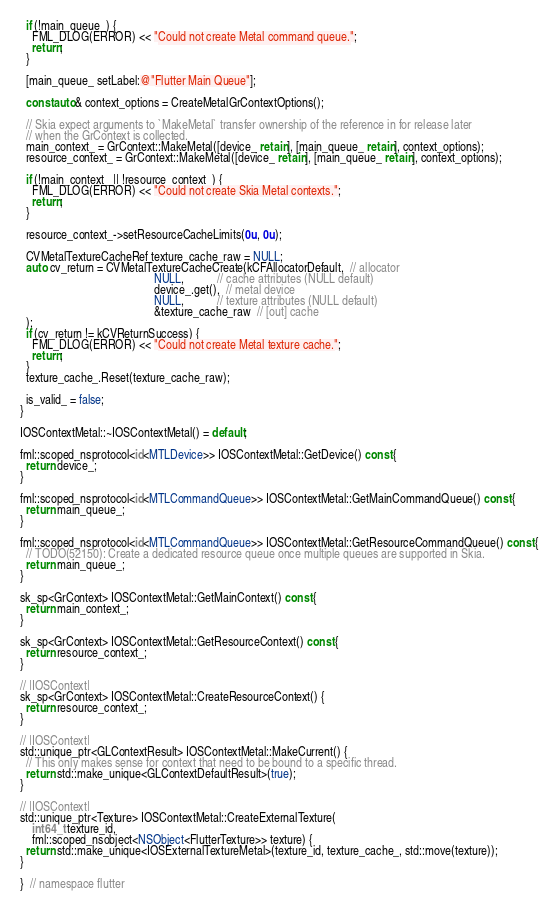Convert code to text. <code><loc_0><loc_0><loc_500><loc_500><_ObjectiveC_>  if (!main_queue_) {
    FML_DLOG(ERROR) << "Could not create Metal command queue.";
    return;
  }

  [main_queue_ setLabel:@"Flutter Main Queue"];

  const auto& context_options = CreateMetalGrContextOptions();

  // Skia expect arguments to `MakeMetal` transfer ownership of the reference in for release later
  // when the GrContext is collected.
  main_context_ = GrContext::MakeMetal([device_ retain], [main_queue_ retain], context_options);
  resource_context_ = GrContext::MakeMetal([device_ retain], [main_queue_ retain], context_options);

  if (!main_context_ || !resource_context_) {
    FML_DLOG(ERROR) << "Could not create Skia Metal contexts.";
    return;
  }

  resource_context_->setResourceCacheLimits(0u, 0u);

  CVMetalTextureCacheRef texture_cache_raw = NULL;
  auto cv_return = CVMetalTextureCacheCreate(kCFAllocatorDefault,  // allocator
                                             NULL,           // cache attributes (NULL default)
                                             device_.get(),  // metal device
                                             NULL,           // texture attributes (NULL default)
                                             &texture_cache_raw  // [out] cache
  );
  if (cv_return != kCVReturnSuccess) {
    FML_DLOG(ERROR) << "Could not create Metal texture cache.";
    return;
  }
  texture_cache_.Reset(texture_cache_raw);

  is_valid_ = false;
}

IOSContextMetal::~IOSContextMetal() = default;

fml::scoped_nsprotocol<id<MTLDevice>> IOSContextMetal::GetDevice() const {
  return device_;
}

fml::scoped_nsprotocol<id<MTLCommandQueue>> IOSContextMetal::GetMainCommandQueue() const {
  return main_queue_;
}

fml::scoped_nsprotocol<id<MTLCommandQueue>> IOSContextMetal::GetResourceCommandQueue() const {
  // TODO(52150): Create a dedicated resource queue once multiple queues are supported in Skia.
  return main_queue_;
}

sk_sp<GrContext> IOSContextMetal::GetMainContext() const {
  return main_context_;
}

sk_sp<GrContext> IOSContextMetal::GetResourceContext() const {
  return resource_context_;
}

// |IOSContext|
sk_sp<GrContext> IOSContextMetal::CreateResourceContext() {
  return resource_context_;
}

// |IOSContext|
std::unique_ptr<GLContextResult> IOSContextMetal::MakeCurrent() {
  // This only makes sense for context that need to be bound to a specific thread.
  return std::make_unique<GLContextDefaultResult>(true);
}

// |IOSContext|
std::unique_ptr<Texture> IOSContextMetal::CreateExternalTexture(
    int64_t texture_id,
    fml::scoped_nsobject<NSObject<FlutterTexture>> texture) {
  return std::make_unique<IOSExternalTextureMetal>(texture_id, texture_cache_, std::move(texture));
}

}  // namespace flutter
</code> 